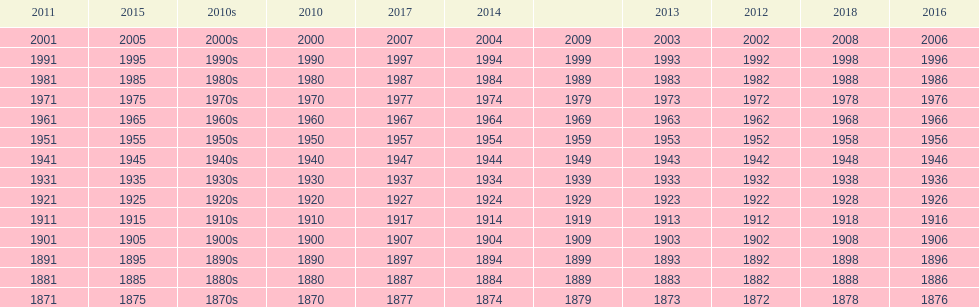What year is after 2018, but does not have a place on the table? 2019. 